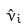<formula> <loc_0><loc_0><loc_500><loc_500>\hat { \nu } _ { i }</formula> 